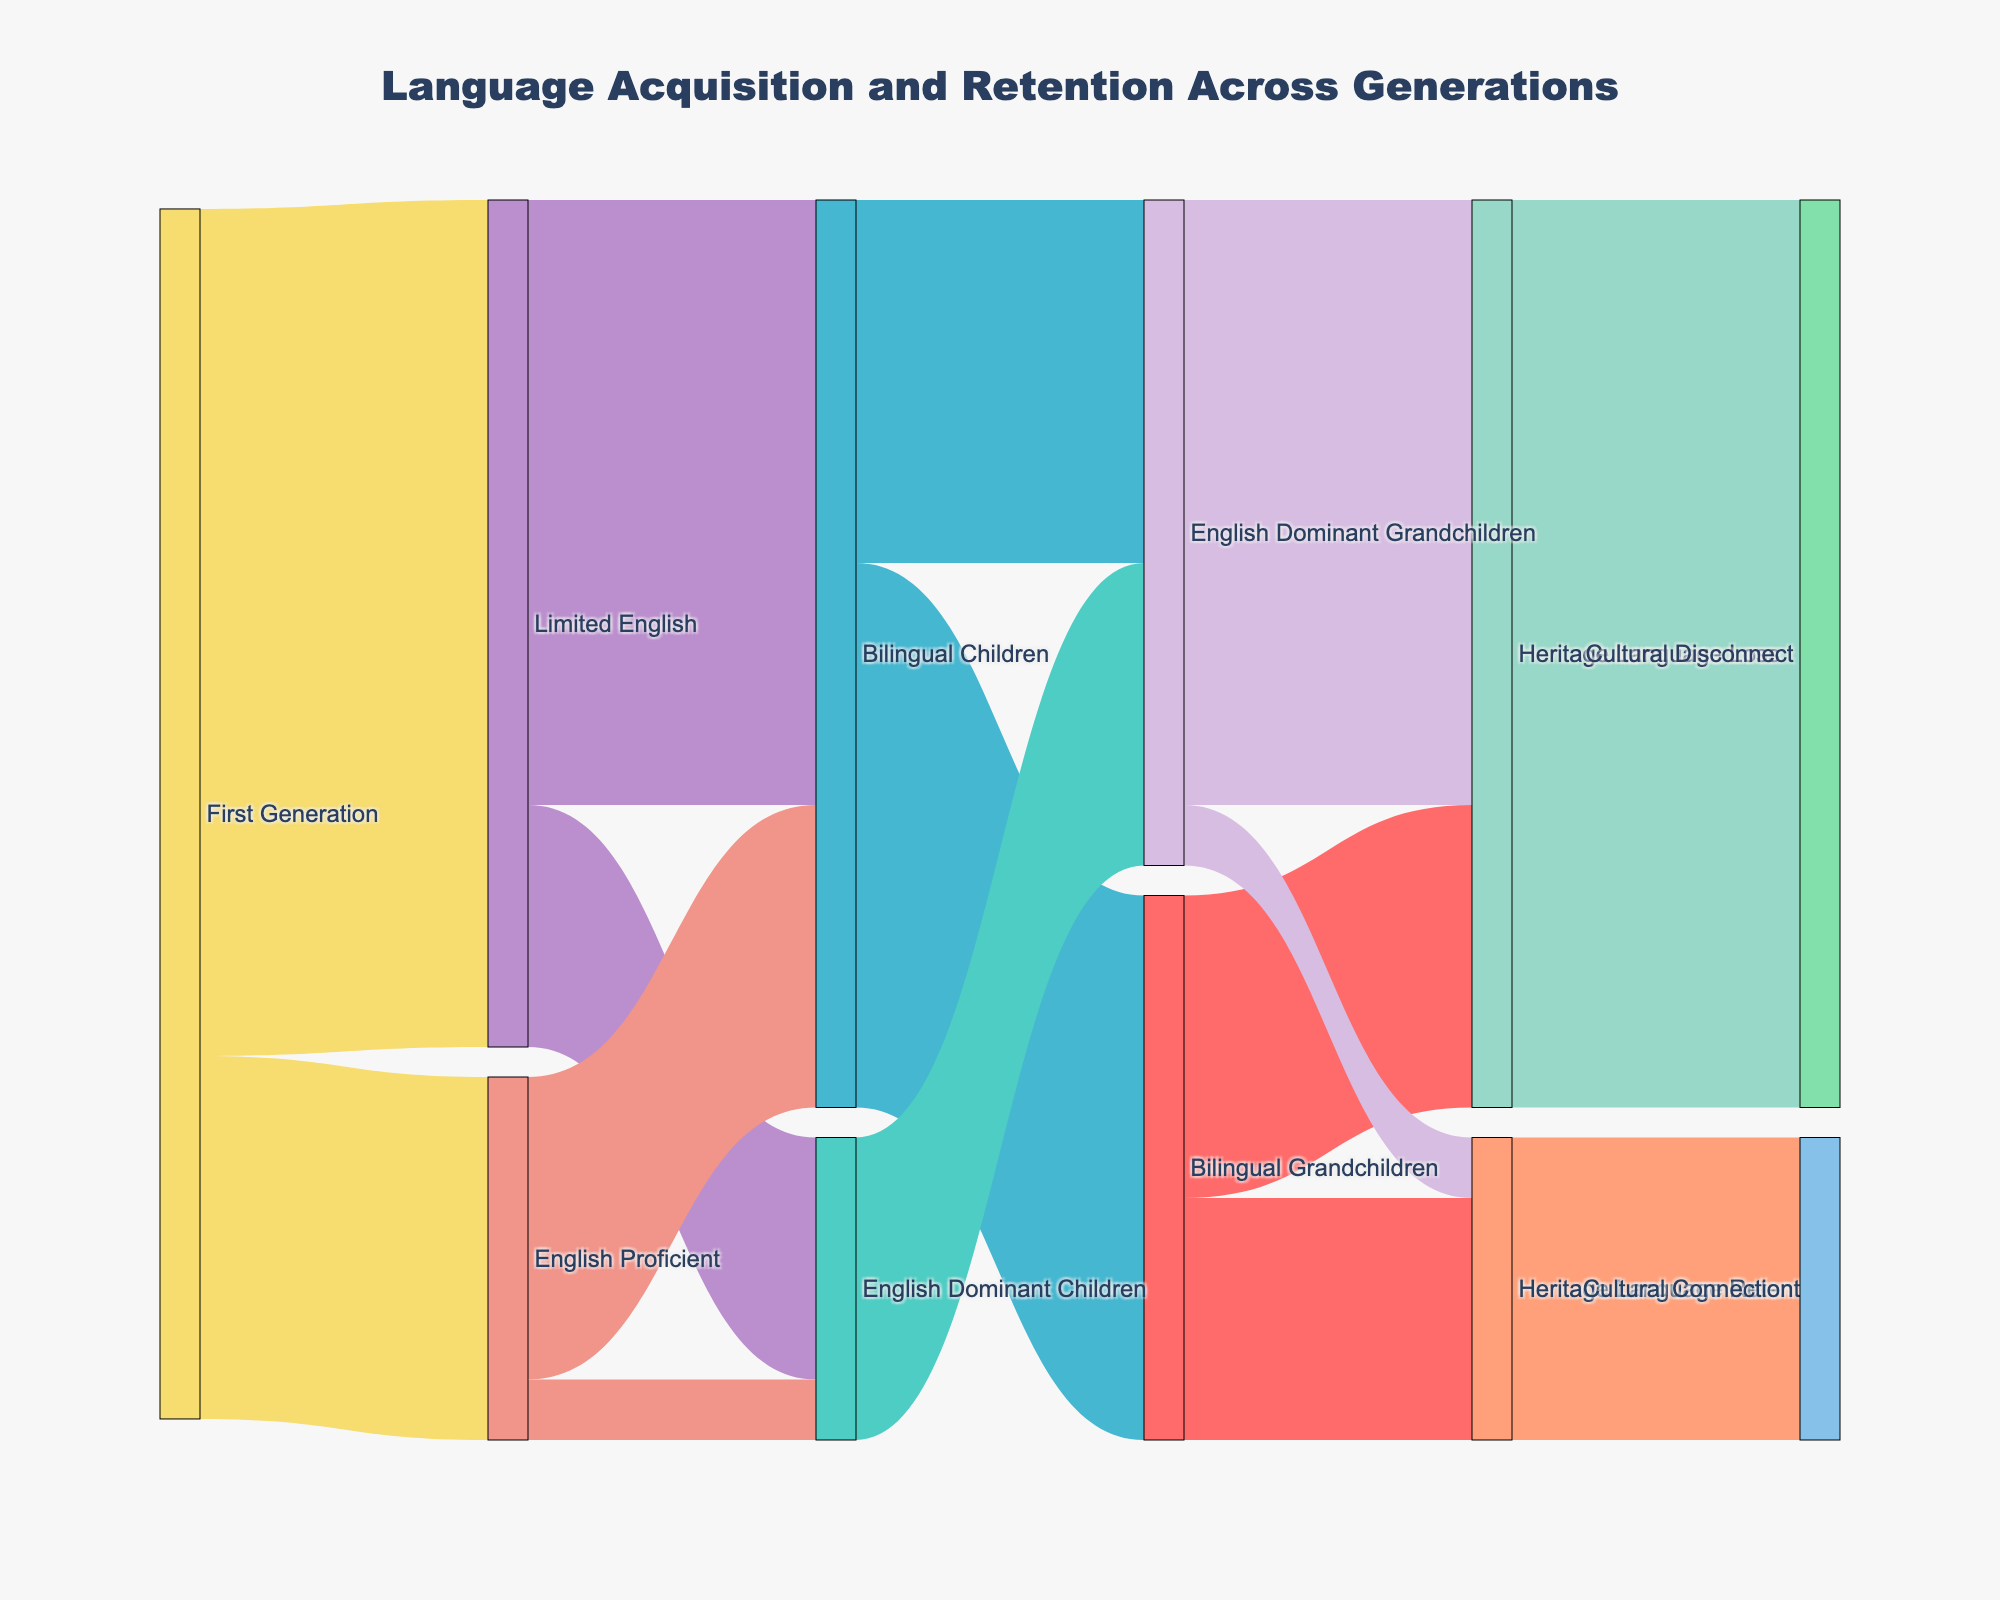What is the title of the figure? The title is provided at the top of the figure. It summarizes the main focus of the diagram.
Answer: "Language Acquisition and Retention Across Generations" What proportion of the First Generation is English Proficient? According to the data, 30 out of 100 individuals in the First Generation are English Proficient. This can be calculated as (30/100) * 100%.
Answer: 30% Which group has the highest flow going into the 'Heritage Language Loss' node? The 'English Dominant Grandchildren' node has the largest flow into 'Heritage Language Loss' with a value of 50. This is evident from the thickness of the link between these nodes.
Answer: English Dominant Grandchildren How many grandchildren retain their heritage language? To determine this, you need to sum up the values of flows that end at 'Heritage Language Retention'. This includes flows from 'Bilingual Grandchildren' (20) and 'English Dominant Grandchildren' (5). The total is 20 + 5.
Answer: 25 What is the major language outcome for children of Limited English parents? Adding the flows from 'Limited English' to 'Bilingual Children' (50) and 'English Dominant Children' (20) shows the distribution. The majority outcome is 'Bilingual Children' with 50.
Answer: Bilingual Children Compare the number of Bilingual Children and English Dominant Children whose parents are English Proficient. According to the data, 'English Proficient' flows to 'Bilingual Children' (25) and 'English Dominant Children' (5). 25 is greater than 5.
Answer: More Bilingual Children than English Dominant Children Which group has the smallest connection to 'Cultural Connection'? The flow from 'English Dominant Grandchildren' to 'Cultural Connection' is only 5. This is the smallest among all the connections leading to 'Cultural Connection'.
Answer: English Dominant Grandchildren Calculate the percentage of 'Limited English' parents whose children are 'Bilingual Children'. The percentage is the value for 'Limited English' to 'Bilingual Children' divided by the total 'Limited English' (100) and then multiplied by 100. (50/70)*100%.
Answer: 71.43% What is the significance of 'Heritage Language Retention' for Bilingual Grandchildren? Bilingual Grandchildren with 'Heritage Language Retention' is 20, and those with 'Heritage Language Loss' is 25. This shows that heritage language retention remains significant but is slightly less common than loss.
Answer: Important but slightly less common What overall trend can be observed regarding the relationship between language proficiency and cultural connection? Generally, higher language proficiency in English is associated with increased cultural disconnection, while heritage language retention links to cultural connection.
Answer: More English proficiency leads to cultural disconnection, retention to connection 